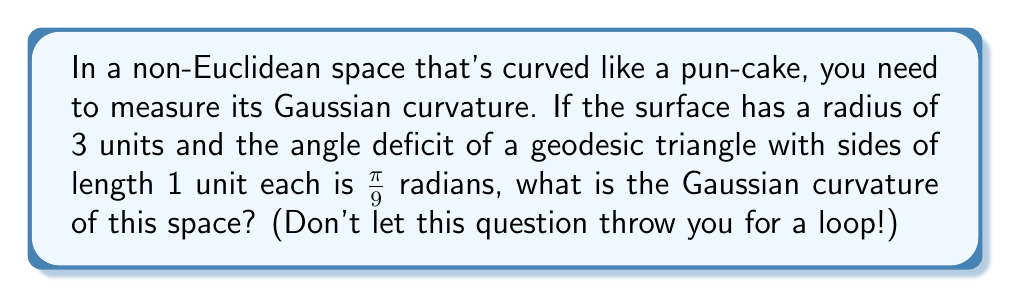Help me with this question. Let's approach this step-by-step:

1) In non-Euclidean geometry, the Gaussian curvature $K$ is related to the angle deficit $\delta$ of a geodesic triangle by the formula:

   $$K = \frac{\delta}{A}$$

   where $A$ is the area of the triangle.

2) We're given that the angle deficit $\delta = \frac{\pi}{9}$ radians.

3) To find the area of the triangle, we need to use the formula for the area of a triangle on a sphere with radius $R$:

   $$A = (\alpha + \beta + \gamma - \pi)R^2$$

   where $\alpha$, $\beta$, and $\gamma$ are the angles of the triangle.

4) We don't know the angles, but we know that in a spherical space:

   $$\alpha + \beta + \gamma = \pi + \delta = \pi + \frac{\pi}{9} = \frac{10\pi}{9}$$

5) Substituting this into the area formula:

   $$A = (\frac{10\pi}{9} - \pi)R^2 = \frac{\pi}{9}R^2$$

6) We're given that $R = 3$, so:

   $$A = \frac{\pi}{9}(3^2) = \frac{\pi}{3}$$

7) Now we can calculate the Gaussian curvature:

   $$K = \frac{\delta}{A} = \frac{\frac{\pi}{9}}{\frac{\pi}{3}} = \frac{1}{3}$$

Therefore, the Gaussian curvature of this space is $\frac{1}{3}$.
Answer: $\frac{1}{3}$ 